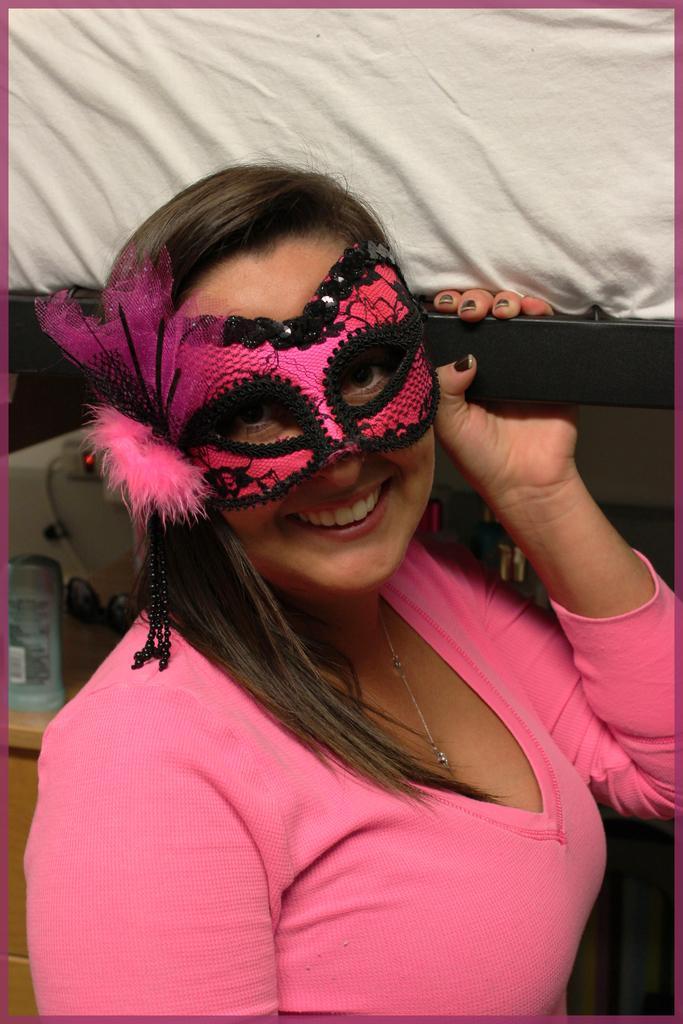Can you describe this image briefly? In this image we can see a woman wearing a mask and holding an object, behind her we can see a bottle, machine and some other objects on the table, also we can see a white color cloth. 